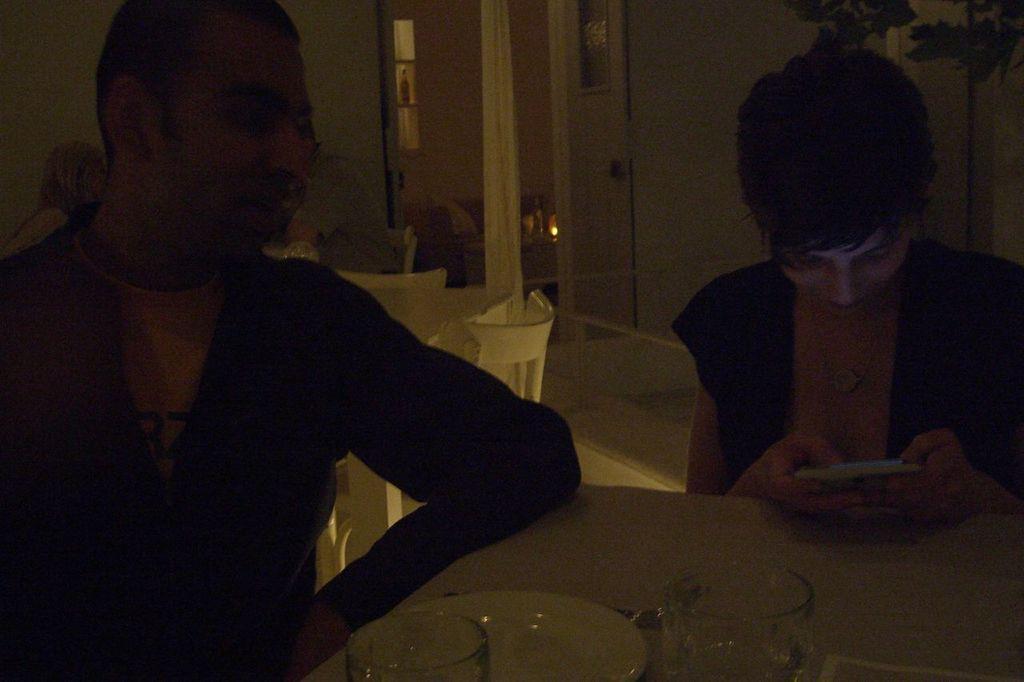Describe this image in one or two sentences. This image is taken indoors. In the background there is a wall. There is a door and there is a curtain. There are many empty chairs. There is a table. There is a person sitting on the chair. On the left side of the image a man is sitting on the chair. On the right side of the image a man is sitting on the chair and holding a mobile phone in her hands. At the bottom of the image there is a table with a tablecloth, a plate, glasses and a few things on it. 